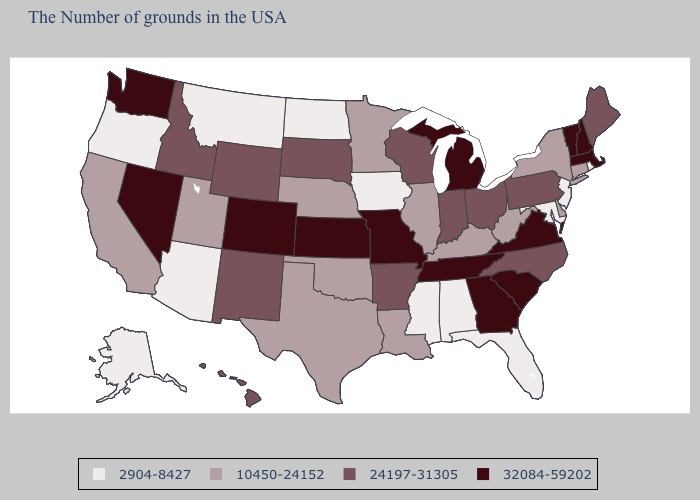Name the states that have a value in the range 32084-59202?
Be succinct. Massachusetts, New Hampshire, Vermont, Virginia, South Carolina, Georgia, Michigan, Tennessee, Missouri, Kansas, Colorado, Nevada, Washington. Which states have the lowest value in the West?
Be succinct. Montana, Arizona, Oregon, Alaska. What is the value of Mississippi?
Be succinct. 2904-8427. What is the lowest value in states that border Wisconsin?
Keep it brief. 2904-8427. What is the highest value in the South ?
Quick response, please. 32084-59202. Among the states that border Oregon , which have the lowest value?
Short answer required. California. What is the highest value in states that border Delaware?
Keep it brief. 24197-31305. Name the states that have a value in the range 10450-24152?
Answer briefly. Connecticut, New York, Delaware, West Virginia, Kentucky, Illinois, Louisiana, Minnesota, Nebraska, Oklahoma, Texas, Utah, California. What is the value of Oklahoma?
Write a very short answer. 10450-24152. Does the first symbol in the legend represent the smallest category?
Keep it brief. Yes. Among the states that border Maryland , which have the lowest value?
Quick response, please. Delaware, West Virginia. Name the states that have a value in the range 10450-24152?
Quick response, please. Connecticut, New York, Delaware, West Virginia, Kentucky, Illinois, Louisiana, Minnesota, Nebraska, Oklahoma, Texas, Utah, California. Among the states that border Indiana , does Kentucky have the lowest value?
Concise answer only. Yes. Among the states that border Connecticut , does Massachusetts have the highest value?
Keep it brief. Yes. Which states hav the highest value in the MidWest?
Short answer required. Michigan, Missouri, Kansas. 